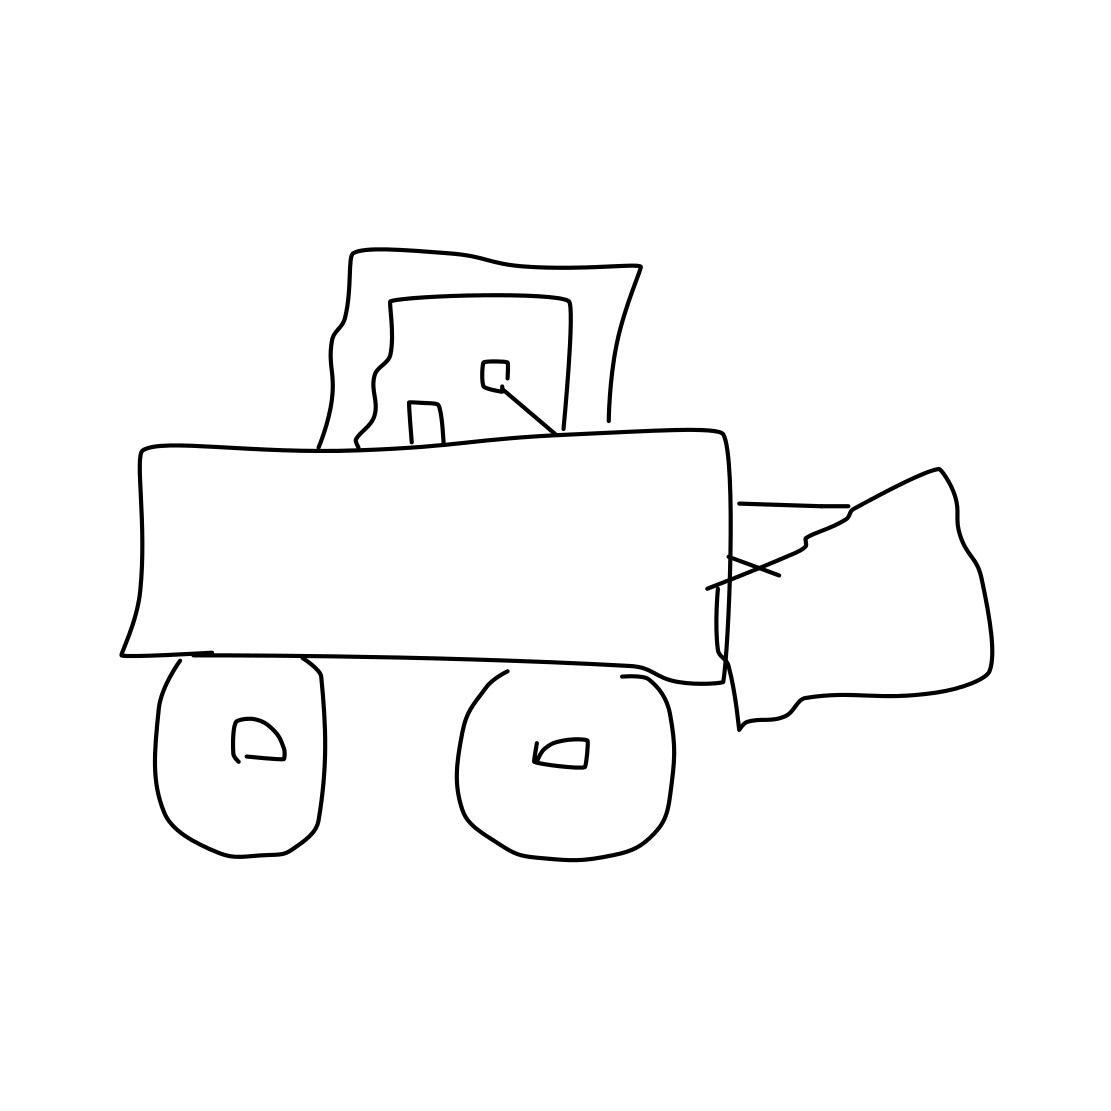Can you tell me more about what this drawing represents? Certainly! The drawing seems to represent a bulldozer, which is a powerful earthmoving vehicle commonly used in construction, mining, and road building. Its distinguishing features include a wide flat blade at the front used for pushing material, a cab for the operator, and wheels or tracks. Despite its simplicity, the image captures the basic silhouette and structure of a bulldozer. 